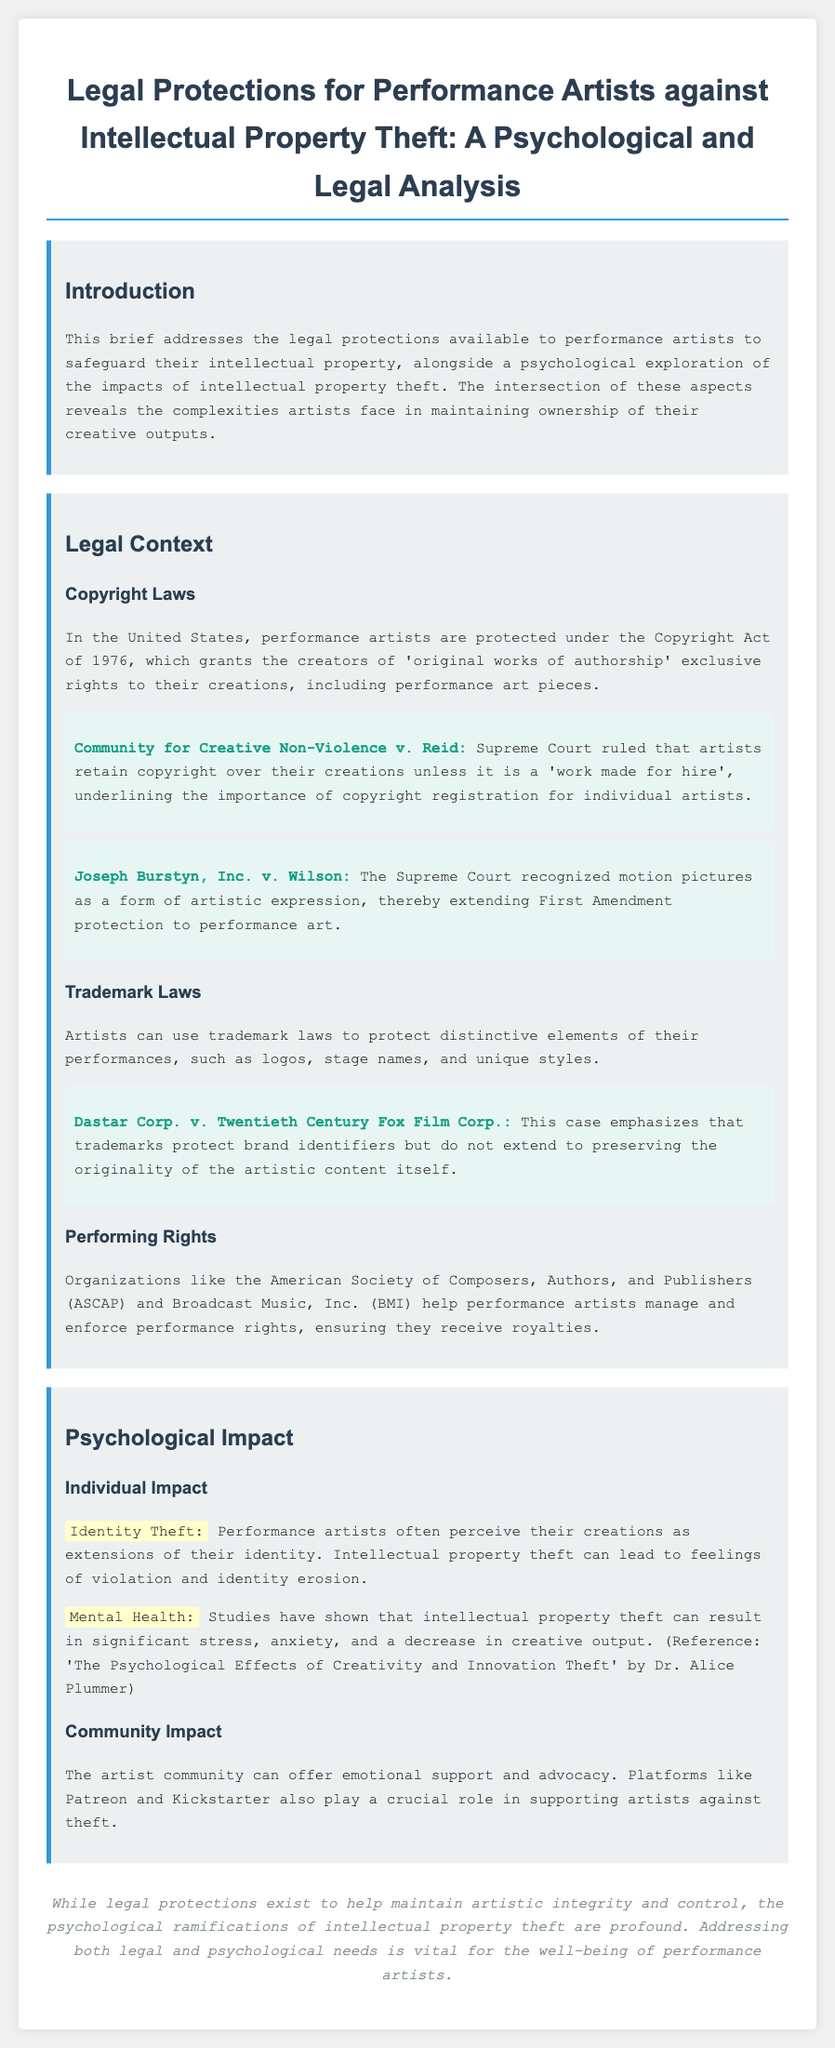What is the title of the brief? The title is explicitly stated at the top of the document, focusing on legal protections for performance artists.
Answer: Legal Protections for Performance Artists against Intellectual Property Theft: A Psychological and Legal Analysis What legal act protects performance artists in the United States? The document cites a specific act that grants exclusive rights to creators, which is part of the legal context section.
Answer: Copyright Act of 1976 Which case emphasizes that artists retain copyright unless it is a 'work made for hire'? This case is highlighted in the legal context regarding copyright laws, indicating a critical ruling by the Supreme Court.
Answer: Community for Creative Non-Violence v. Reid What psychological effect can intellectual property theft have on performance artists? The document discusses a specific psychological consequence that relates to the artist's perception of their work and its impact on their well-being.
Answer: Identity Theft What organization helps performance artists manage and enforce performance rights? This organization is mentioned as playing a significant role in ensuring artists receive royalties and is part of the organizing rights section.
Answer: ASCAP How does the document describe the impact of theft on mental health? A study mentioned in the document provides insight into the psychological ramifications of intellectual property theft.
Answer: Significant stress, anxiety, and a decrease in creative output What is the highlighted role of community platforms like Patreon for artists? The document discusses the support provided by these platforms in relation to the emotional and practical challenges artists face.
Answer: Supporting artists against theft What kind of support can the artist community provide? The document indicates the type of emotional and practical support offered to artists through their community.
Answer: Emotional support and advocacy 